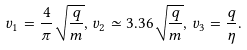Convert formula to latex. <formula><loc_0><loc_0><loc_500><loc_500>v _ { 1 } = \frac { 4 } { \pi } \sqrt { \frac { q } { m } } , \, v _ { 2 } \simeq 3 . 3 6 \sqrt { \frac { q } { m } } , \, v _ { 3 } = \frac { q } { \eta } .</formula> 